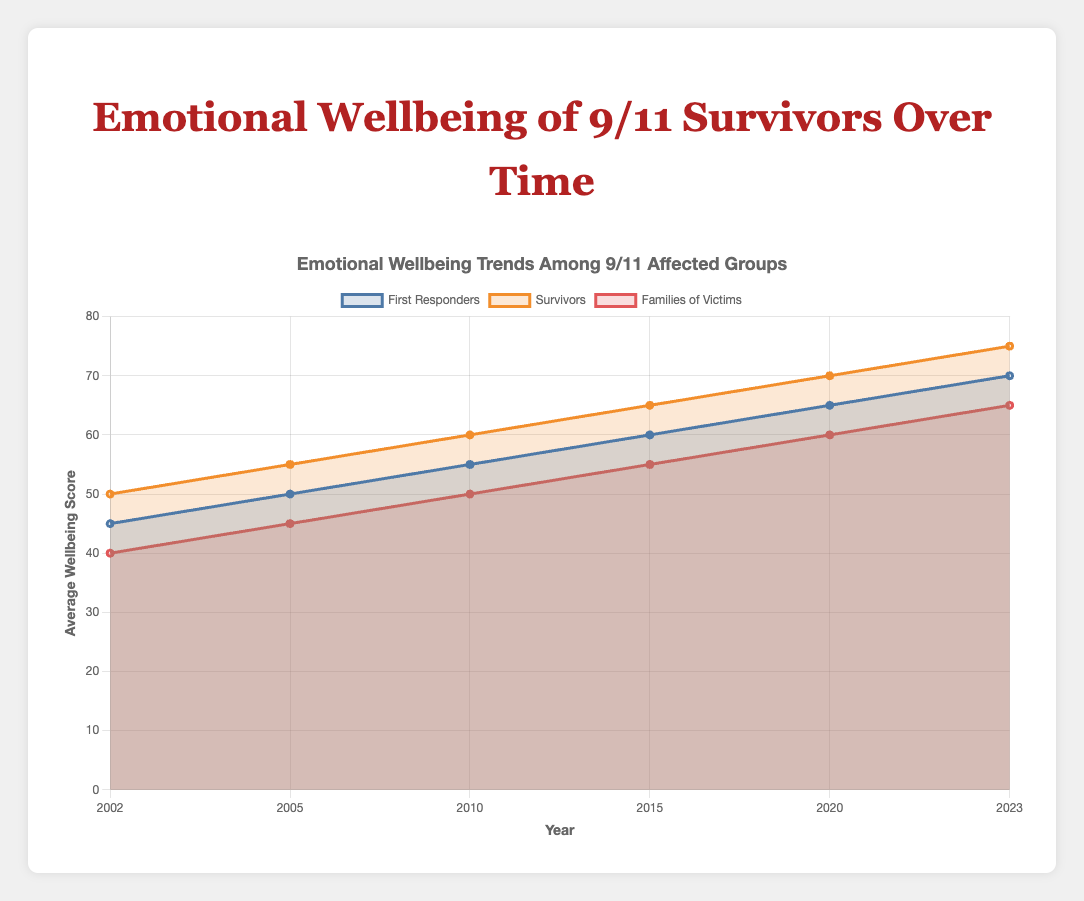What's the trend in the emotional wellbeing scores of First Responders from 2002 to 2023? The line representing First Responders starts at 45 in 2002 and increases steadily each subsequent year to 50 in 2005, 55 in 2010, 60 in 2015, 65 in 2020, and finally reaches 70 in 2023.
Answer: Increasing Which group had the lowest emotional wellbeing score in 2002? By looking at the graph for the year 2002, the Families of Victims group had the lowest score, which is 40.
Answer: Families of Victims By how much did the emotional wellbeing score of Survivors increase from 2010 to 2023? The Survivors' score in 2010 was 60 and in 2023 it is 75. The increase is calculated by subtracting the 2010 score from the 2023 score (75 - 60).
Answer: 15 Compare the emotional wellbeing scores between First Responders and Families of Victims in 2023. Who has a higher score, and by how much? In 2023, the First Responders have a score of 70, while Families of Victims have 65. Subtract the Families of Victims' score from the First Responders' score (70 - 65).
Answer: First Responders, by 5 How did the emotional wellbeing scores for Families of Victims change from 2002 to 2023? The Families of Victims' score was 40 in 2002 and rose steadily reaching 45 in 2005, 50 in 2010, 55 in 2015, 60 in 2020, and finally 65 in 2023.
Answer: Increasing What's the difference in emotional wellbeing scores between Survivors and First Responders in 2015? In 2015, the Survivors' score is 65 and the First Responders' score is 60. Subtract the First Responders' score from the Survivors' score (65 - 60).
Answer: 5 Which group had the highest increase in emotional wellbeing scores from 2002 to 2023? Calculate the difference for each group from 2002 to 2023. First Responders: 70 - 45 = 25, Survivors: 75 - 50 = 25, Families of Victims: 65 - 40 = 25. All groups had the same increase.
Answer: All groups In 2020, by how much did the emotional wellbeing score of Families of Victims differ from that of Survivors? The score for Families of Victims in 2020 was 60, and for Survivors, it was 70. Subtract the Families of Victims' score from the Survivors' score (70 - 60).
Answer: 10 What's the average emotional wellbeing score of First Responders across all the years shown? Sum the scores of First Responders for all years and divide by the number of years. (45 + 50 + 55 + 60 + 65 + 70) / 6.
Answer: 57.5 